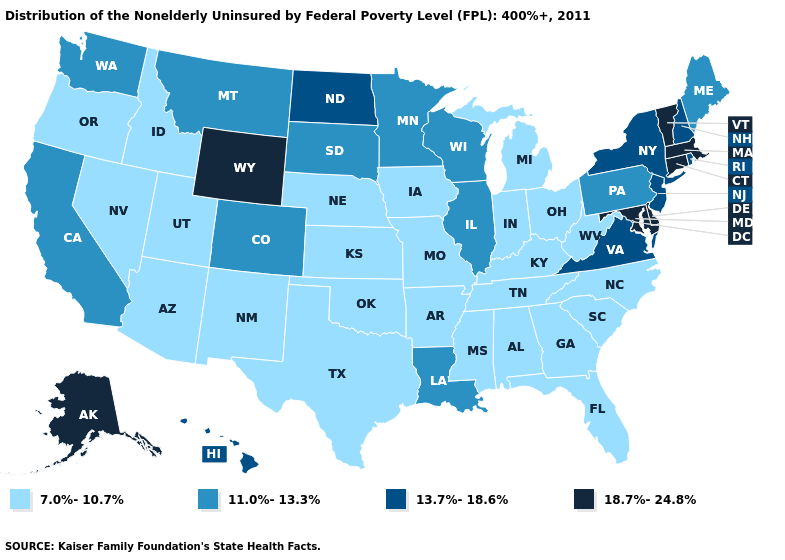What is the value of South Carolina?
Write a very short answer. 7.0%-10.7%. Which states hav the highest value in the MidWest?
Answer briefly. North Dakota. Does Florida have the lowest value in the USA?
Answer briefly. Yes. What is the lowest value in the Northeast?
Answer briefly. 11.0%-13.3%. What is the lowest value in the MidWest?
Be succinct. 7.0%-10.7%. What is the value of Idaho?
Write a very short answer. 7.0%-10.7%. Does Mississippi have a lower value than Oklahoma?
Answer briefly. No. Name the states that have a value in the range 13.7%-18.6%?
Give a very brief answer. Hawaii, New Hampshire, New Jersey, New York, North Dakota, Rhode Island, Virginia. What is the value of Iowa?
Give a very brief answer. 7.0%-10.7%. What is the value of Rhode Island?
Quick response, please. 13.7%-18.6%. What is the lowest value in states that border Mississippi?
Answer briefly. 7.0%-10.7%. What is the lowest value in states that border Idaho?
Write a very short answer. 7.0%-10.7%. Is the legend a continuous bar?
Write a very short answer. No. Name the states that have a value in the range 11.0%-13.3%?
Short answer required. California, Colorado, Illinois, Louisiana, Maine, Minnesota, Montana, Pennsylvania, South Dakota, Washington, Wisconsin. What is the value of Mississippi?
Answer briefly. 7.0%-10.7%. 